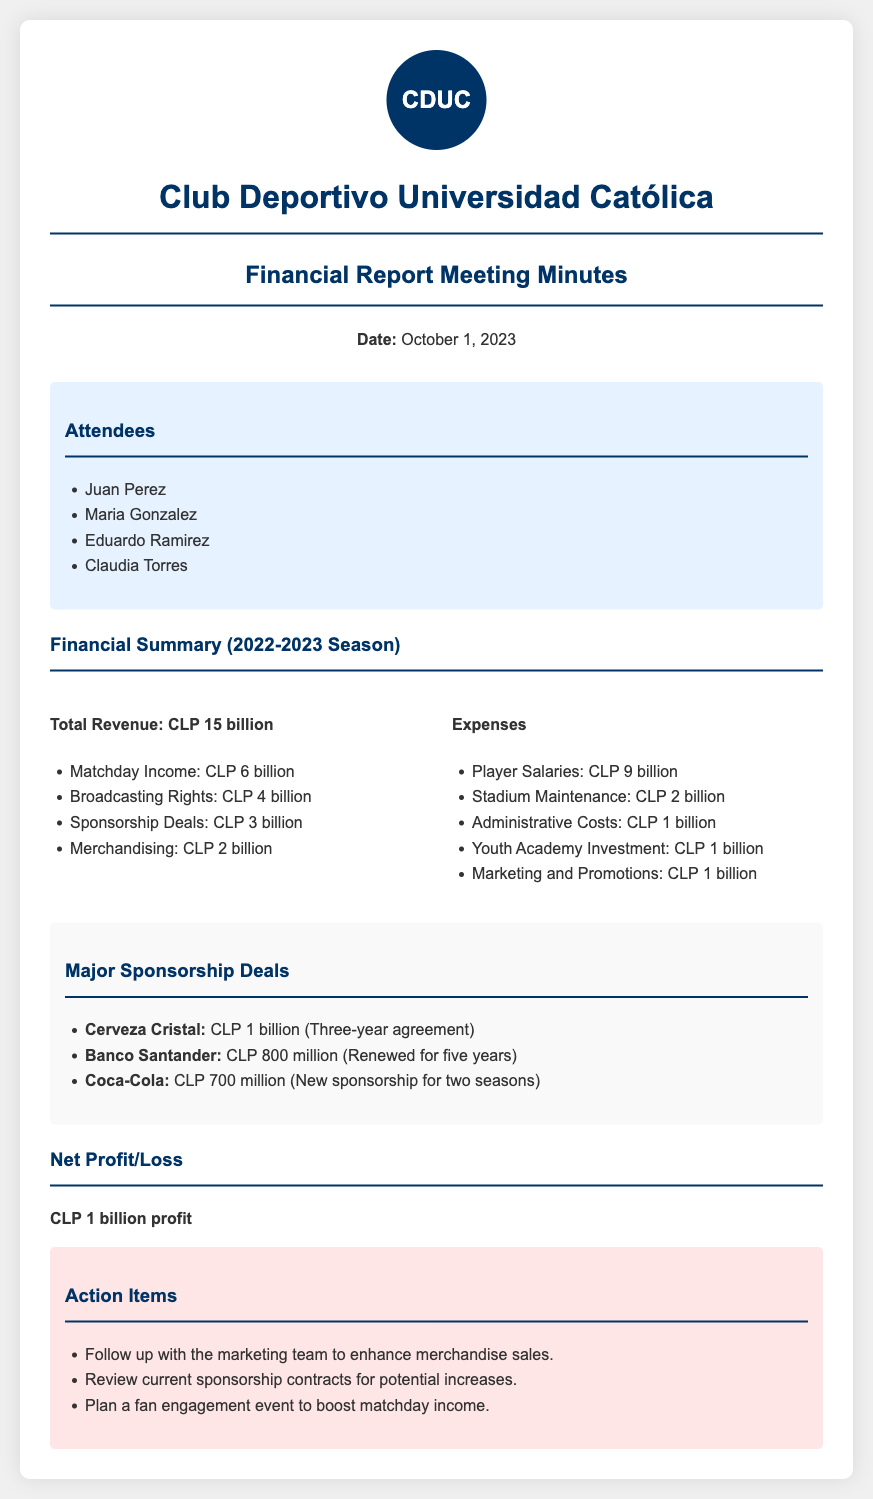What is the total revenue? The total revenue is listed at the beginning of the financial summary, showing the figure for the 2022-2023 season.
Answer: CLP 15 billion What is the amount received from broadcasting rights? Broadcasting rights revenue is specifically itemized in the financial summary under revenue sources.
Answer: CLP 4 billion How much is allocated for player salaries? Player salaries are mentioned in the expenses section of the report.
Answer: CLP 9 billion What is the profit declared for the season? The net profit/loss is summarized at the end of the financial report.
Answer: CLP 1 billion profit Which company has a sponsorship deal worth CLP 1 billion? The details of major sponsorship deals are listed, indicating the value of individual contracts.
Answer: Cerveza Cristal How many attendees were present at the meeting? The attendees section lists the names of the participants in the meeting.
Answer: 4 What is the total amount from sponsorship deals? Sponsorship deals are summarized with their respective amounts, which can be added together.
Answer: CLP 3 billion What is one action item discussed in the meeting? Action items are specified to provide follow-up tasks from the financial report meeting.
Answer: Follow up with the marketing team to enhance merchandise sales For how long is the agreement with Banco Santander renewed? The renewal duration for the Banco Santander sponsorship is noted in the sponsorship deals section.
Answer: Five years 